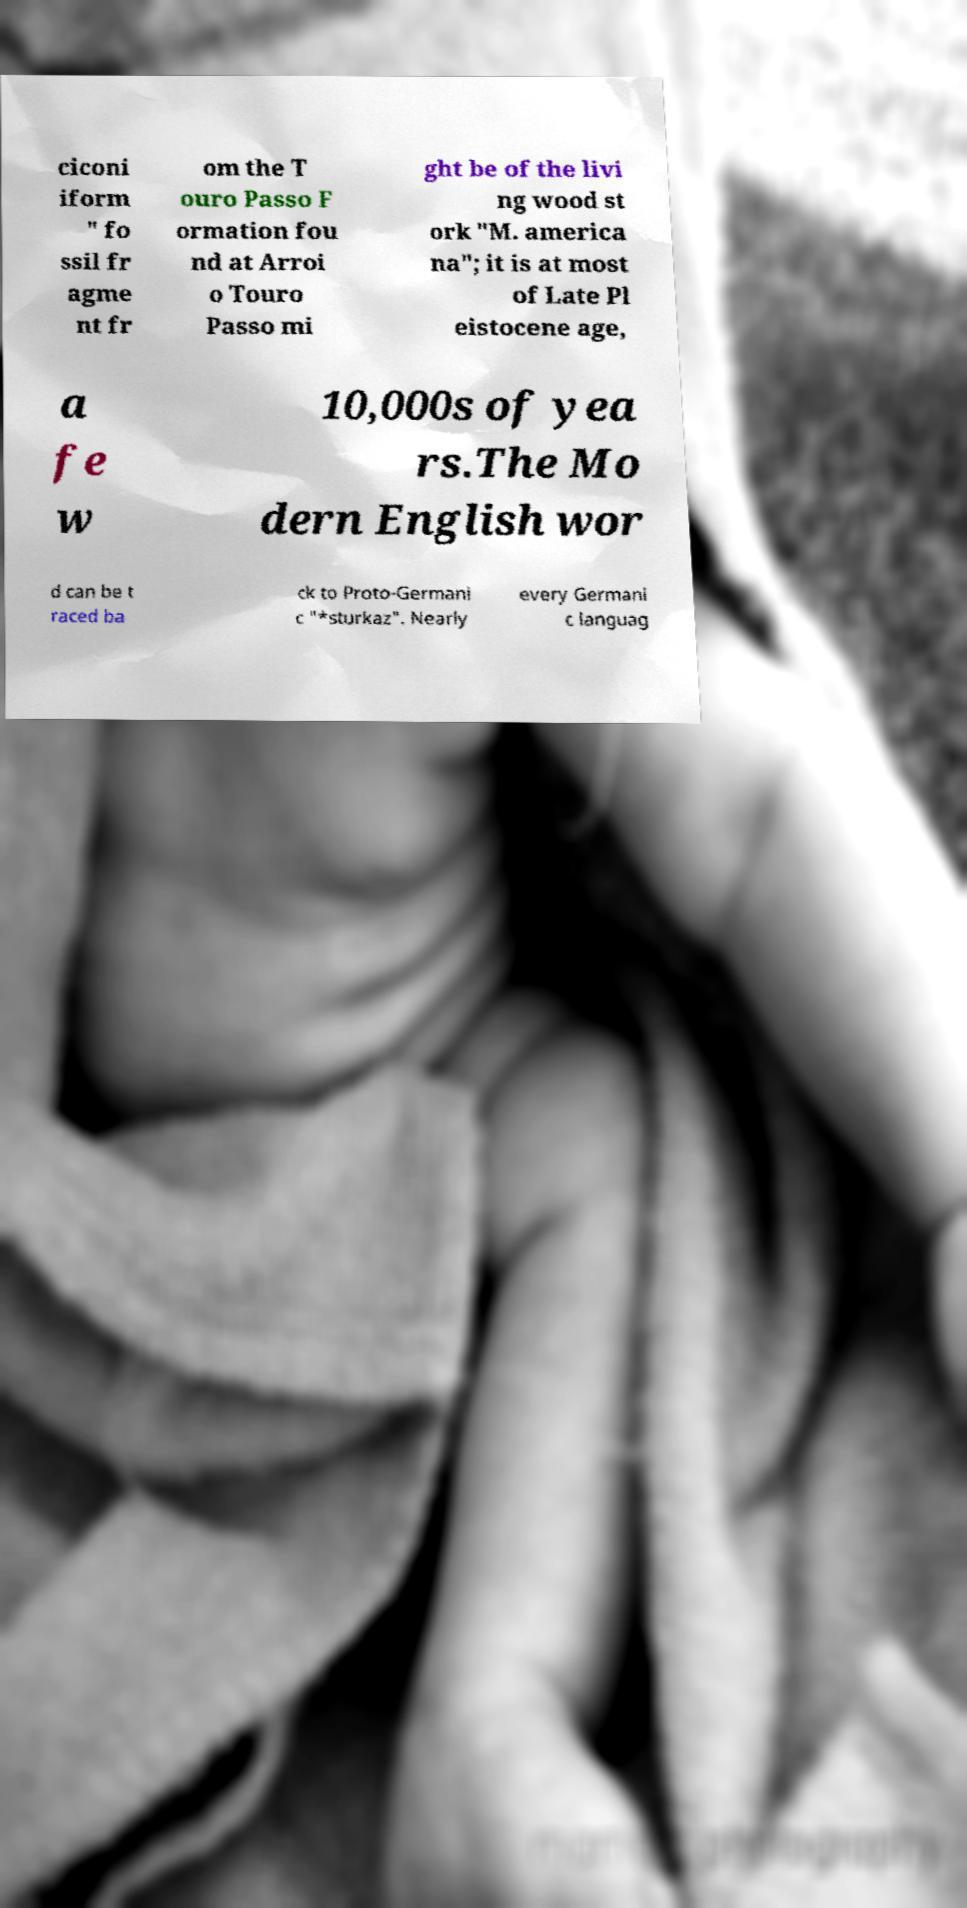Can you accurately transcribe the text from the provided image for me? ciconi iform " fo ssil fr agme nt fr om the T ouro Passo F ormation fou nd at Arroi o Touro Passo mi ght be of the livi ng wood st ork "M. america na"; it is at most of Late Pl eistocene age, a fe w 10,000s of yea rs.The Mo dern English wor d can be t raced ba ck to Proto-Germani c "*sturkaz". Nearly every Germani c languag 